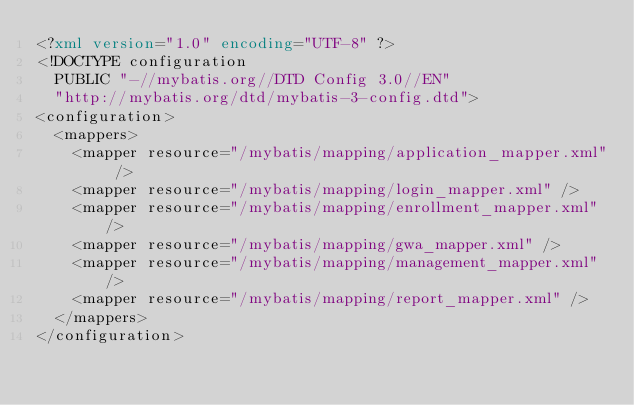<code> <loc_0><loc_0><loc_500><loc_500><_XML_><?xml version="1.0" encoding="UTF-8" ?>
<!DOCTYPE configuration
  PUBLIC "-//mybatis.org//DTD Config 3.0//EN"
  "http://mybatis.org/dtd/mybatis-3-config.dtd">
<configuration>
	<mappers>
		<mapper resource="/mybatis/mapping/application_mapper.xml" />
		<mapper resource="/mybatis/mapping/login_mapper.xml" />
		<mapper resource="/mybatis/mapping/enrollment_mapper.xml" />
		<mapper resource="/mybatis/mapping/gwa_mapper.xml" />
		<mapper resource="/mybatis/mapping/management_mapper.xml" />
		<mapper resource="/mybatis/mapping/report_mapper.xml" />
	</mappers>
</configuration>
</code> 